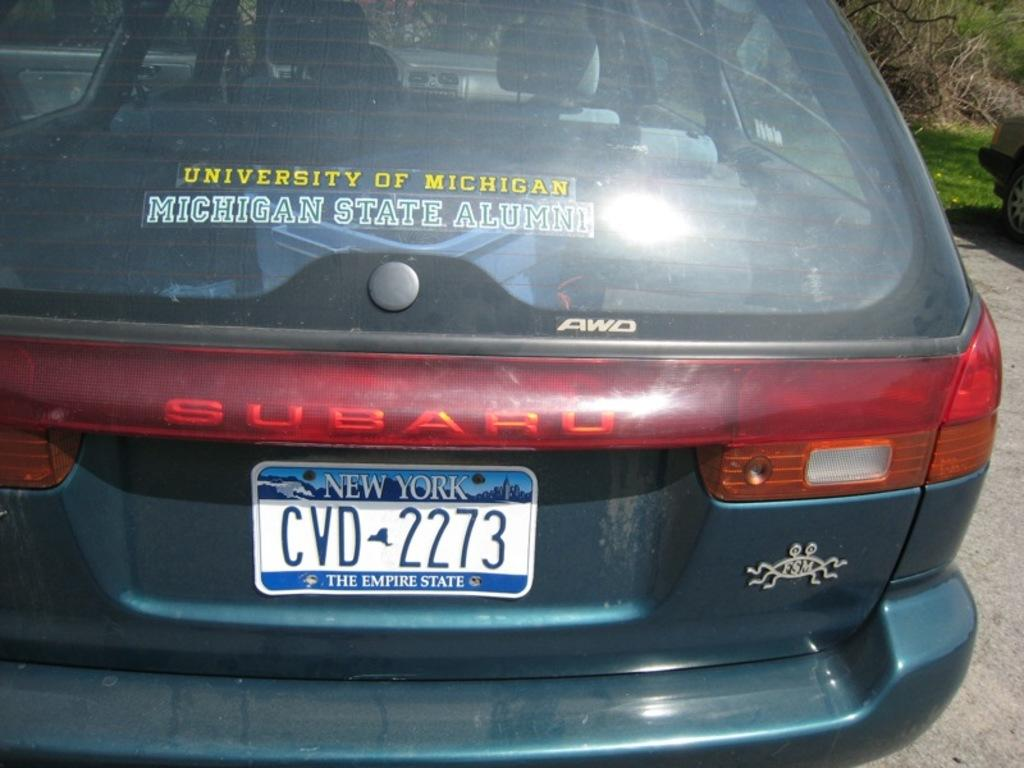<image>
Write a terse but informative summary of the picture. Car that is Subaru with a New York the empire state tag 